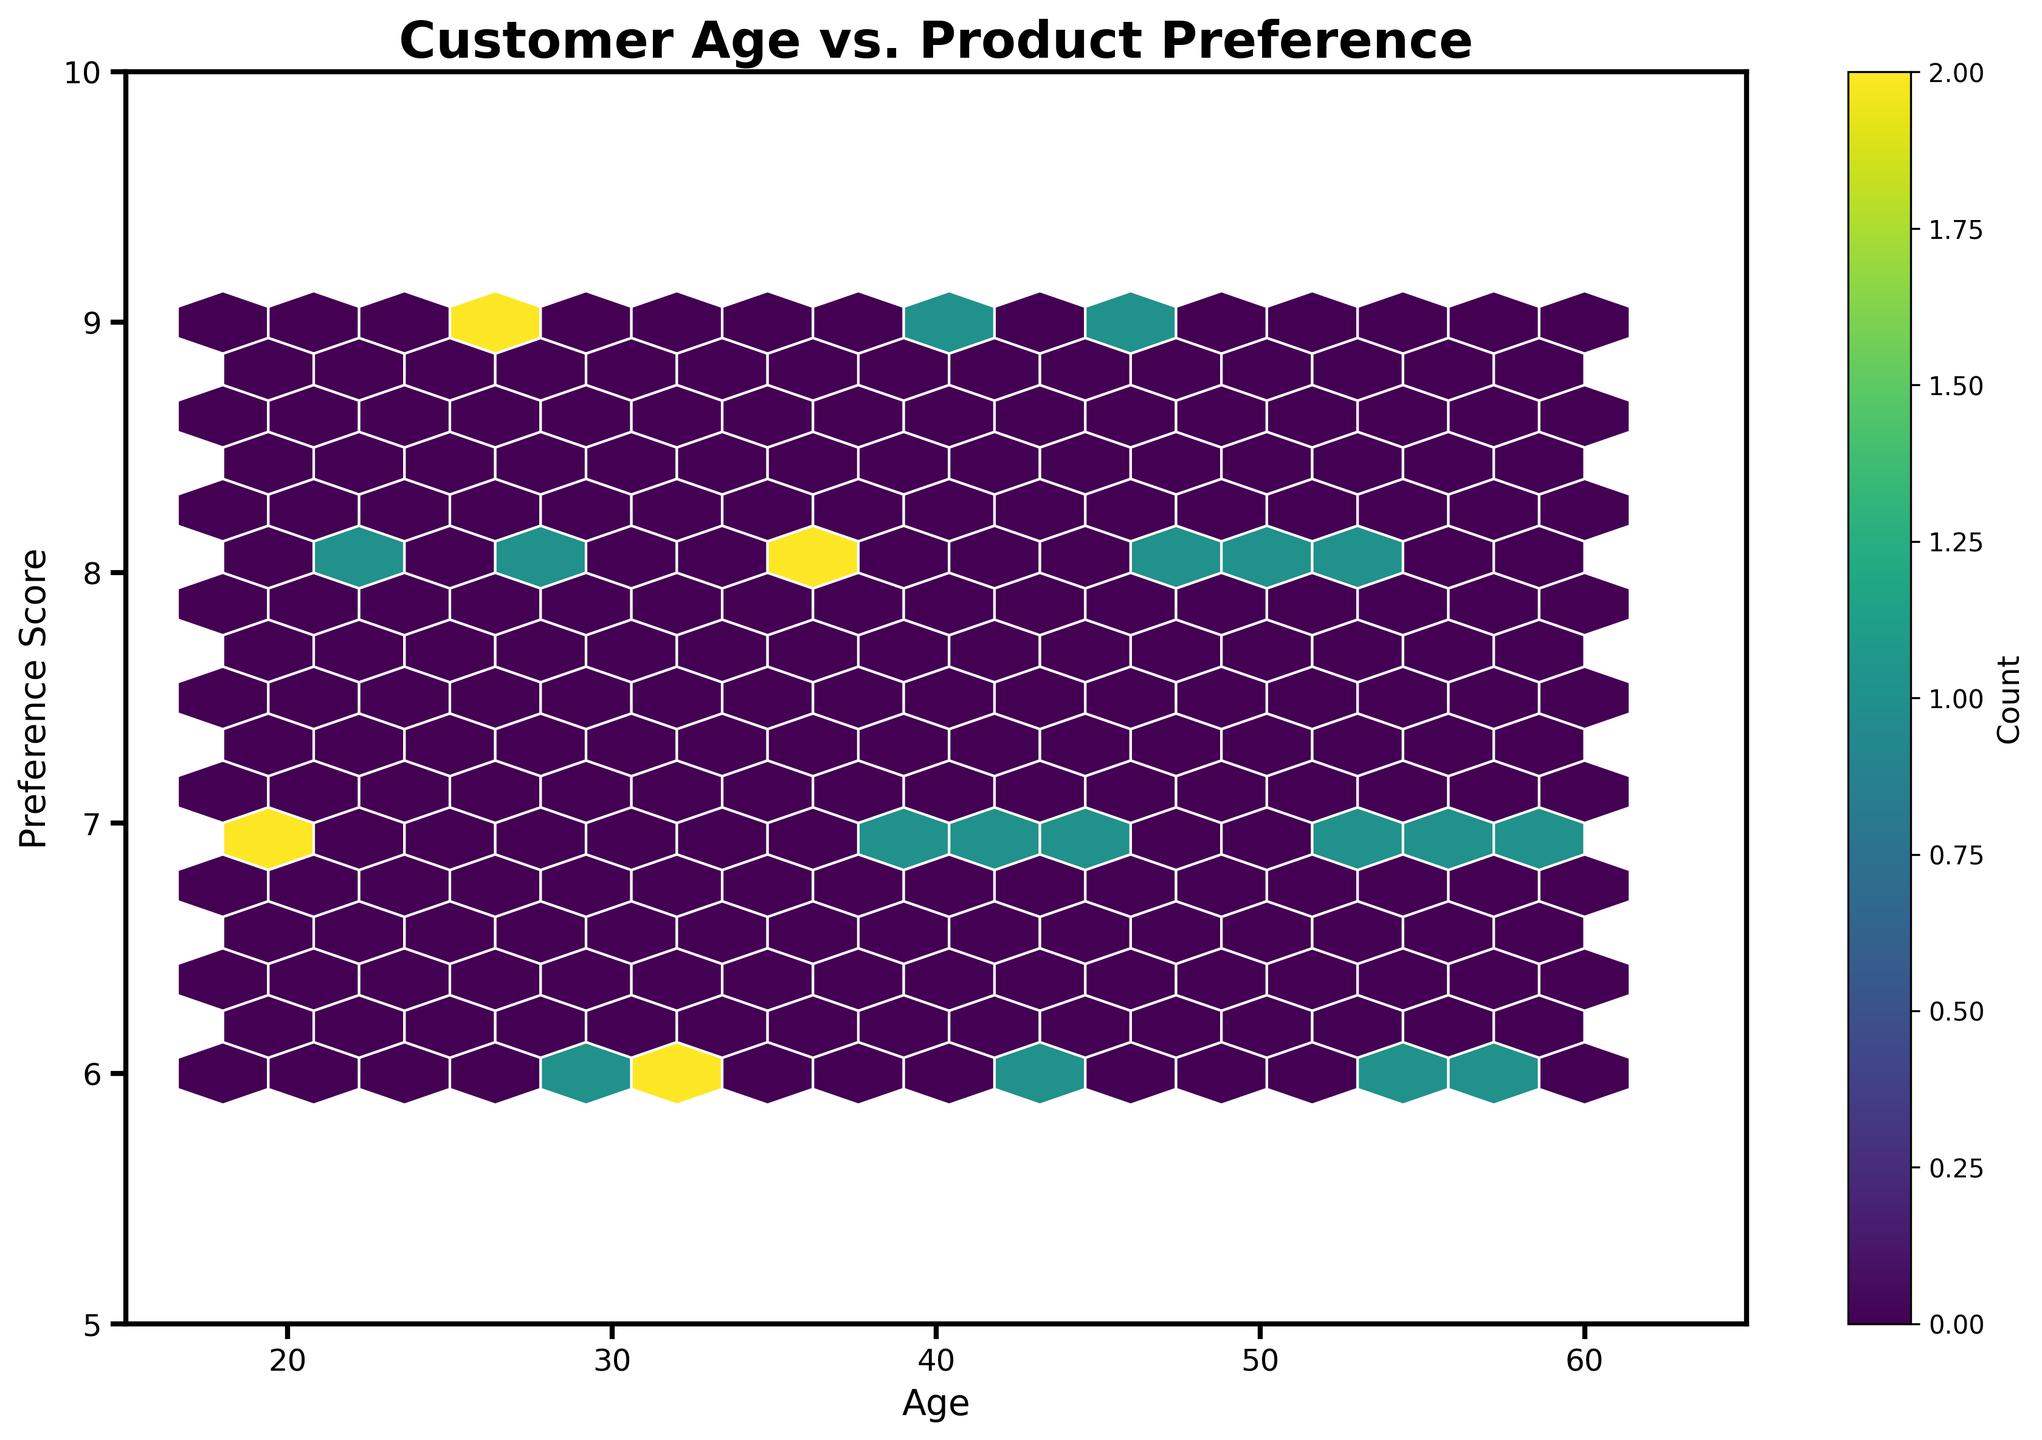What is the title of the hexbin plot? The title of the hexbin plot is displayed at the top of the figure, providing context for what the plot represents.
Answer: Customer Age vs. Product Preference What are the labels on the x and y axes? The labels on the x and y axes are displayed directly below the x-axis and directly to the left of the y-axis, indicating what the plotted data represents.
Answer: Age, Preference Score What's the range of ages plotted on the x-axis? The x-axis range is determined by the limits set on the axis, which can be seen at the bottom of the plot.
Answer: 15 to 65 How many preference score levels are shown on the y-axis? The y-axis shows the distinct preference scores between the lowest and highest values, which are marked along the left side of the plot.
Answer: 5 to 10 Do younger customers (ages 18-25) show higher preference scores compared to older customers (ages 50-60)? To determine this, observe the density of hexagons at different parts of the age range and compare the bin colors indicating the number of data points.
Answer: Yes What age group has the highest concentration of customers with a preference score of 9? By looking at the densest hexagon (darker) along the preference score level of 9 and noting the corresponding age range on the x-axis, we can identify this group.
Answer: Ages 25-35 Which preference score has the widest range of ages associated with it? Observe which horizontal line (preference score) has the most varied distribution of hexagons across the x-axis.
Answer: Preference Score 7 Is there a significant age group with a low preference score (5-6)? By checking the density and location of hexagons in the preference score range of 5-6, we can conclude if there's a notable number of data points.
Answer: No significant group Are there more customers in their 40s or in their 50s, and how can you tell? Compare the density of hexagons in the age ranges of 40-49 and 50-59, observing which range has more and/or darker hexagons.
Answer: More in their 40s Looking at the color bar, what does a darker hexagon signify in terms of customer count? The color bar's label and colors indicate that darker hexagons represent a higher count of customers within that hexagon.
Answer: Higher count 